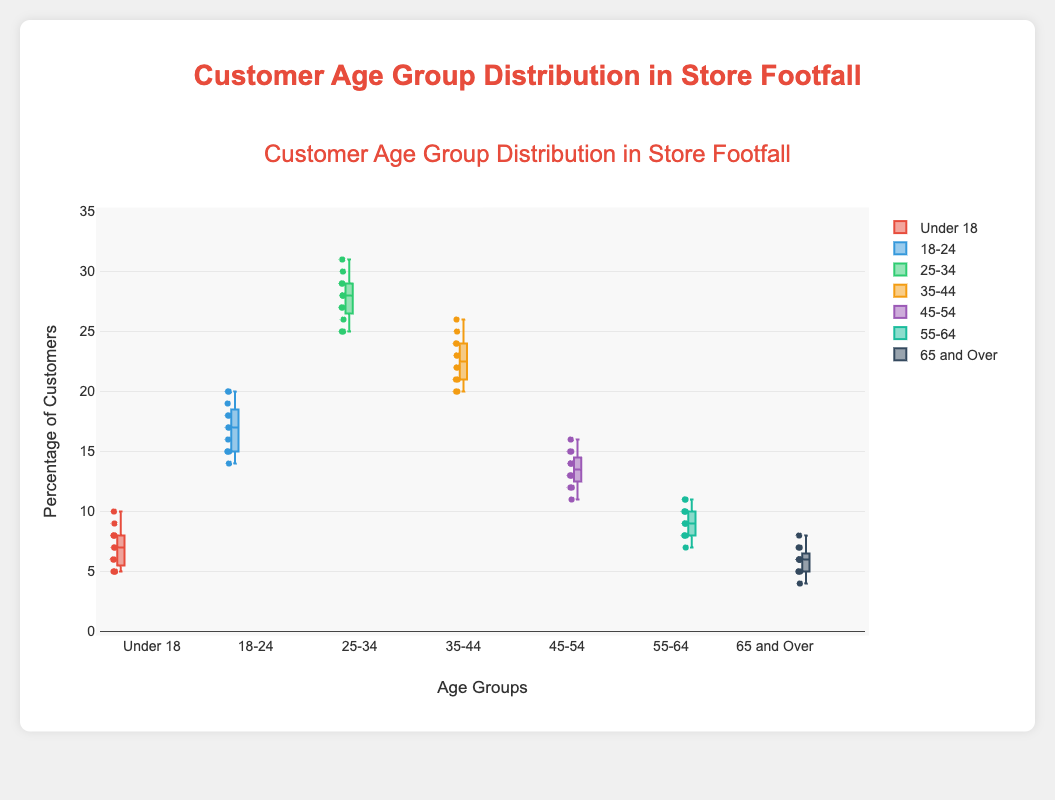What's the median percentage of customers in the age group "18-24"? To find the median, identify the middle value when the percentages are listed in order. For "18-24", the sorted list is [14, 15, 15, 15, 16, 17, 17, 18, 18, 18, 19, 20]. The middle values are the 6th and 7th, both are 17.
Answer: 17 Which age group has the highest median percentage of customers? By examining the boxes, you see that the "25-34" age group has the highest median value around 28.
Answer: 25-34 What's the range of values for the "55-64" age group? The range is the difference between the maximum and minimum values. For "55-64", the maximum is 11 and the minimum is 7, so the range is 11 - 7 = 4.
Answer: 4 Which age group has the smallest interquartile range (IQR)? The IQR is the difference between the third quartile (Q3) and the first quartile (Q1). By inspecting the plot, "Under 18" has the smallest IQR as the box is very compact.
Answer: Under 18 Which age group has the most outliers? In a box plot, outliers are shown as individual points beyond the whiskers. Count these points for each group. The "65 and Over" age group has several points beyond the whisker.
Answer: 65 and Over What's the median difference in percentage of customers between "35-44" and "45-54"? The median for "35-44" is around 23, and for "45-54" it is around 13. The difference is 23 - 13 = 10.
Answer: 10 Which age group has the largest whisker-to-whisker range? The total range is the difference between the maximum and minimum whisker points. For "25-34", the min is 25 and the max is 31, giving a range of 31 - 25 = 6.
Answer: 25-34 What's the upper whisker value for the age group "Under 18"? The upper whisker generally represents the highest data point within 1.5 IQR of the upper quartile. For "Under 18", it’s around 10.
Answer: 10 